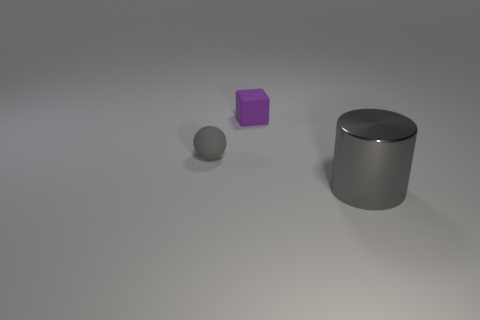Subtract all cylinders. How many objects are left? 2 Subtract 1 cylinders. How many cylinders are left? 0 Add 3 cyan matte spheres. How many objects exist? 6 Subtract 0 red spheres. How many objects are left? 3 Subtract all green cylinders. Subtract all yellow spheres. How many cylinders are left? 1 Subtract all brown cylinders. How many cyan balls are left? 0 Subtract all brown matte spheres. Subtract all tiny gray balls. How many objects are left? 2 Add 3 tiny gray objects. How many tiny gray objects are left? 4 Add 2 large cyan metal objects. How many large cyan metal objects exist? 2 